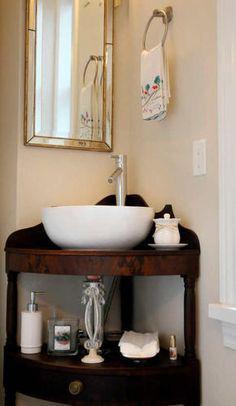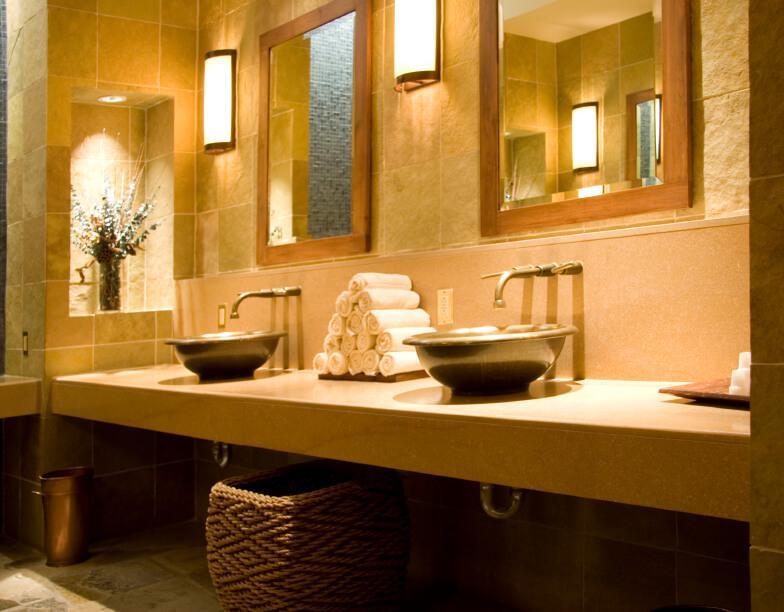The first image is the image on the left, the second image is the image on the right. Analyze the images presented: Is the assertion "There is a double vanity and a single vanity." valid? Answer yes or no. Yes. The first image is the image on the left, the second image is the image on the right. Analyze the images presented: Is the assertion "There is one vase with flowers in the right image." valid? Answer yes or no. Yes. 